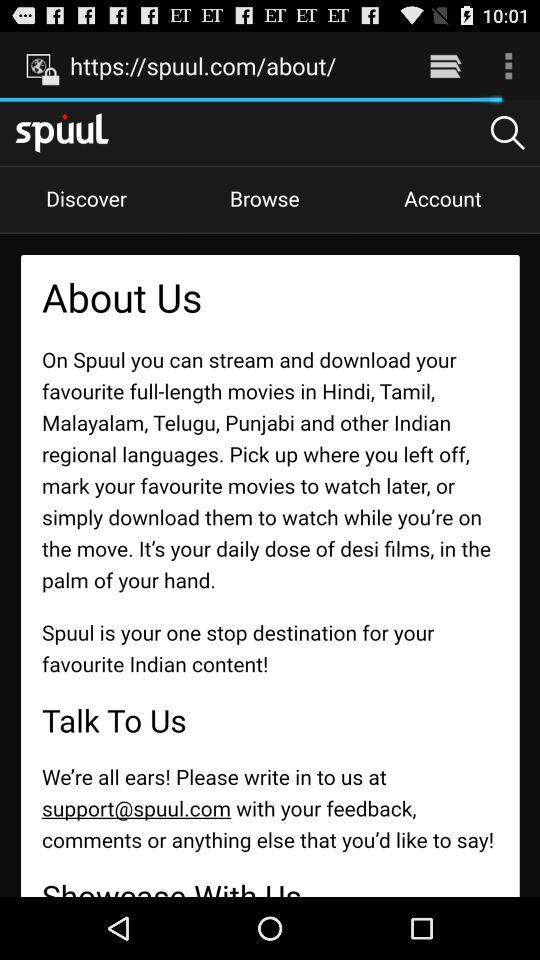What is the email address at which I can give feedback? You can give feedback at support@spuul.com. 